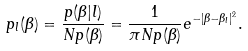Convert formula to latex. <formula><loc_0><loc_0><loc_500><loc_500>p _ { l } ( \beta ) = \frac { p ( \beta | l ) } { N p ( \beta ) } = \frac { 1 } { \pi N p ( \beta ) } e ^ { - | \beta - \beta _ { l } | ^ { 2 } } .</formula> 